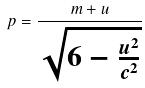<formula> <loc_0><loc_0><loc_500><loc_500>p = \frac { m + u } { \sqrt { 6 - \frac { u ^ { 2 } } { c ^ { 2 } } } }</formula> 